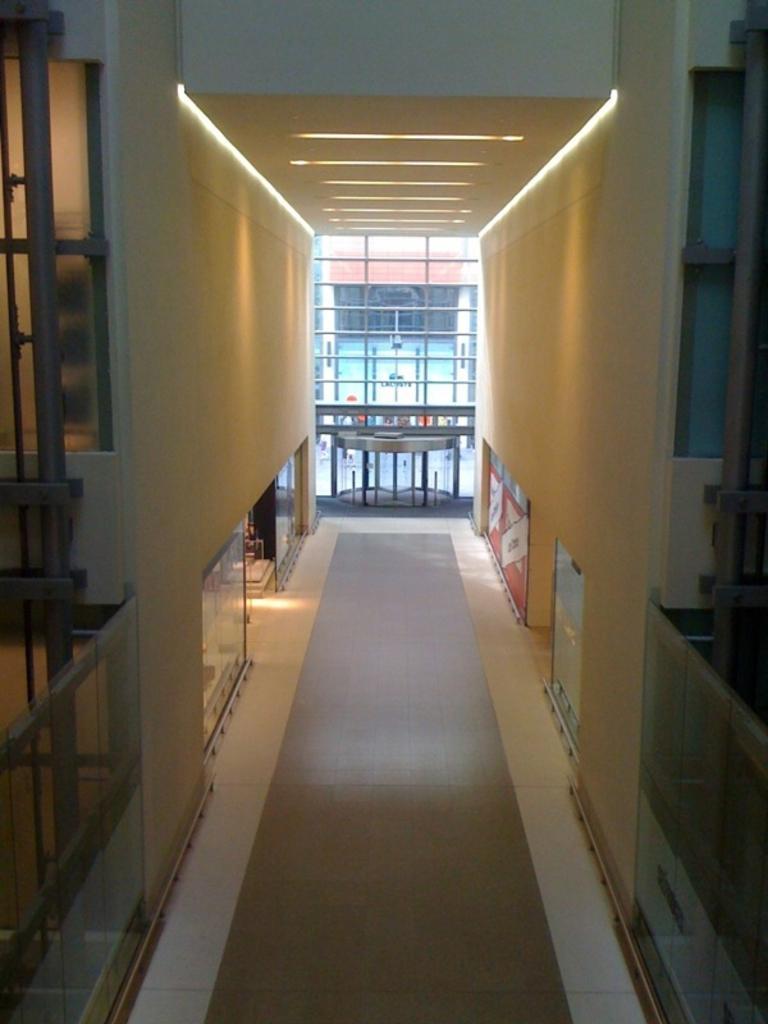Describe this image in one or two sentences. in this image there is a wall at left side of this image and right side of this image as well, and there is a window glass in middle of this image. 